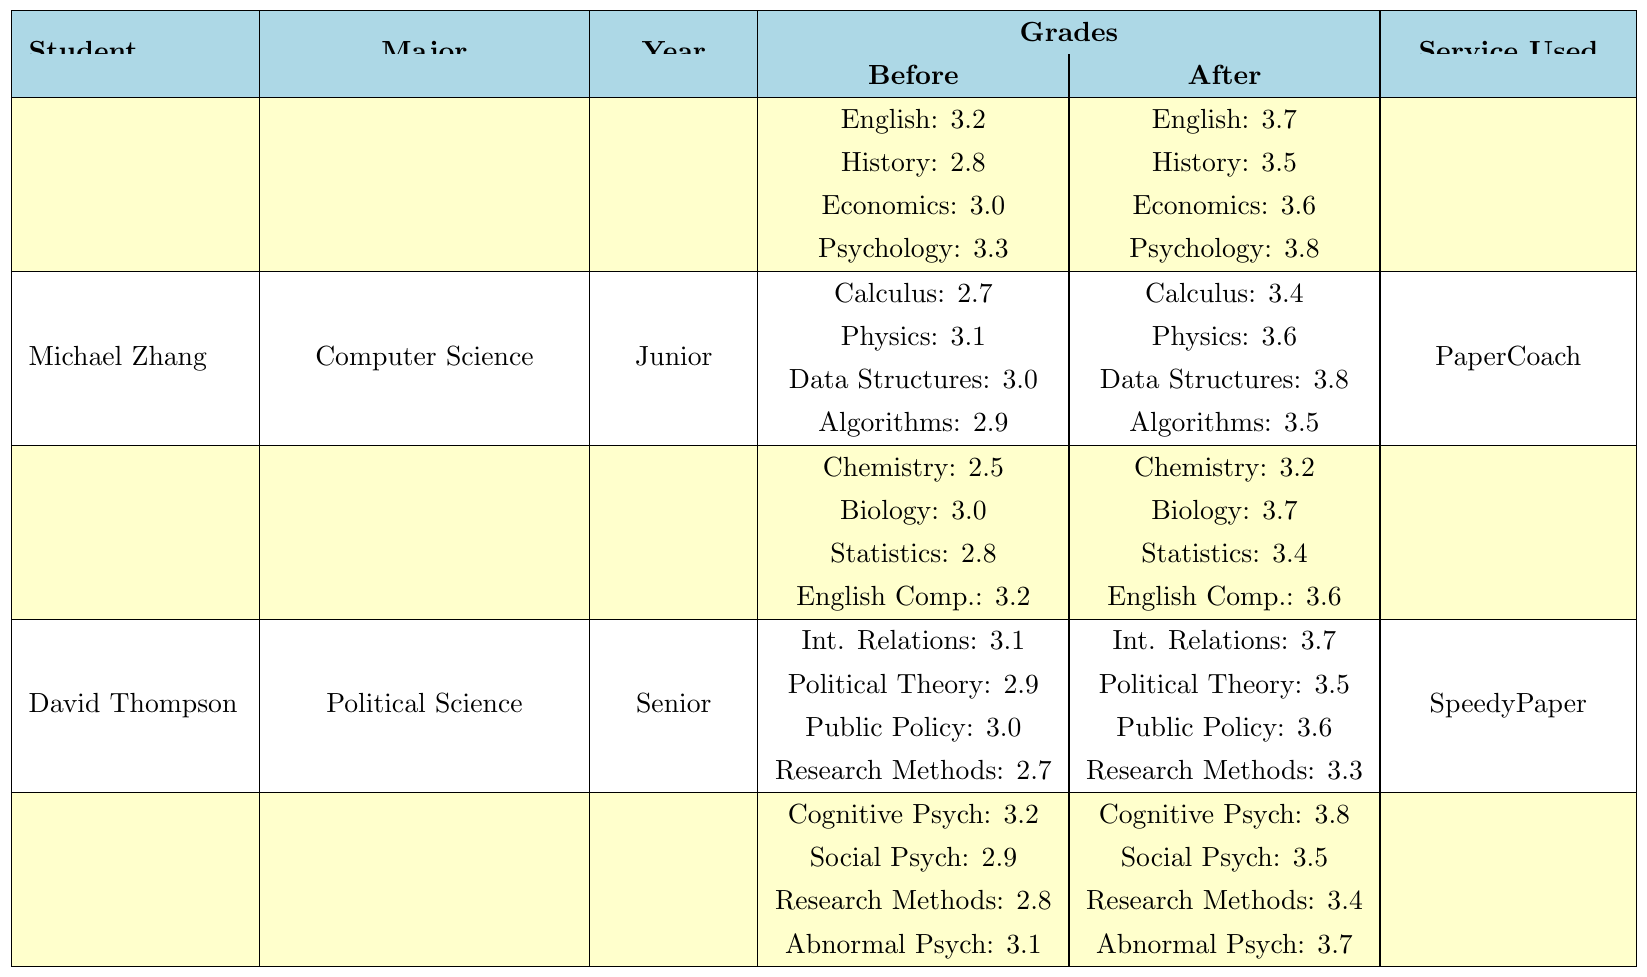What was Emily Johnson's English grade before using the service? The table indicates that Emily Johnson's English grade before using the service was 3.2
Answer: 3.2 Which service did David Thompson use? The table states that David Thompson used the "SpeedyPaper" service
Answer: SpeedyPaper What was the improvement in Sophia Rodriguez's Biology grade? The Biology grade improved from 3.0 to 3.7, so the improvement is 3.7 - 3.0 = 0.7
Answer: 0.7 How many subjects did Michael Zhang see a grade improvement in? Michael Zhang had grades recorded in four subjects listed, and he experienced improvements in all four.
Answer: 4 What was Olivia Patel's Research Methods grade after using the service? The table shows that Olivia Patel's Research Methods grade after using the service was 3.4
Answer: 3.4 Did any student improve their grade by more than 1 point in any subject? By examining the table, the largest improvement is seen in Sophia Rodriguez's Chemistry, which increased 0.7, so no student improved by more than 1 point in any subject.
Answer: No Calculate the average improvement in grades for Emily Johnson. Emily Johnson had the following improvements: English (0.5), History (0.7), Economics (0.6), and Psychology (0.5). Summing these gives 0.5 + 0.7 + 0.6 + 0.5 = 2.3. Dividing by 4 subjects gives an average improvement of 2.3 / 4 = 0.575
Answer: 0.575 What was the highest 'before' grade among all subjects in the table? Scanning the 'before' grades, the highest is 3.3 in both Psychology (Emily Johnson) and Abnormal Psychology (Olivia Patel)
Answer: 3.3 Who improved their grades the most in terms of percentage for their respective courses? To find the percentage improvement, we calculate the percentage increase for each student. For example, for Emily Johnson's Psychology: (0.5 / 3.3) * 100 = 15.15%. After calculating all improvements, the highest percentage improvement is in Chemistry for Sophia Rodriguez: (0.7 / 2.5) * 100 = 28%.
Answer: Sophia Rodriguez in Chemistry Did any student have the same 'before' and 'after' grades across all subjects? By examining the table, all students had grade improvements in their subjects, meaning no student had the same 'before' and 'after' grades across any subject.
Answer: No 